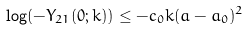Convert formula to latex. <formula><loc_0><loc_0><loc_500><loc_500>\log ( - Y _ { 2 1 } ( 0 ; k ) ) \leq - c _ { 0 } k ( a - a _ { 0 } ) ^ { 2 }</formula> 